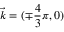Convert formula to latex. <formula><loc_0><loc_0><loc_500><loc_500>\vec { k } = ( \mp \frac { 4 } { 3 } \pi , 0 )</formula> 